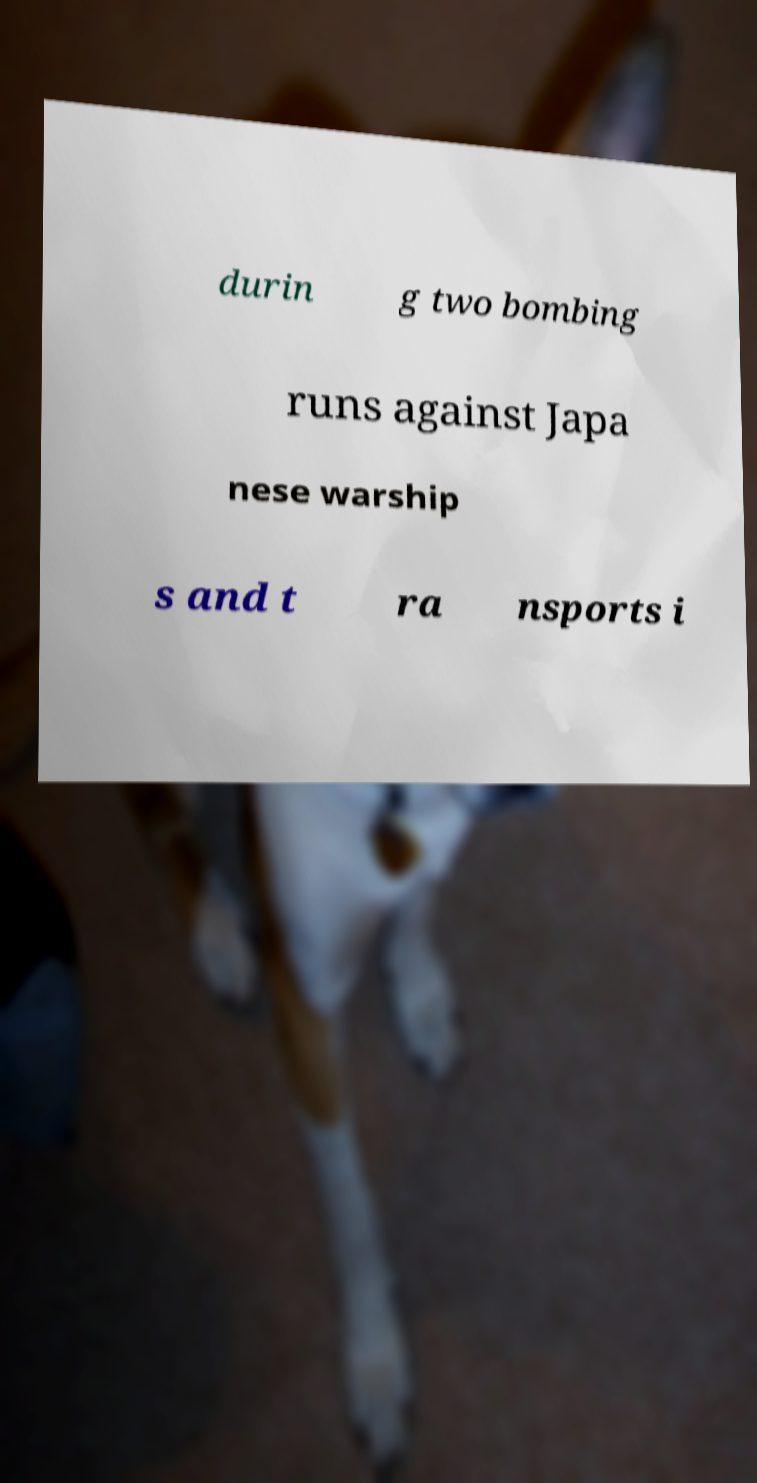Can you read and provide the text displayed in the image?This photo seems to have some interesting text. Can you extract and type it out for me? durin g two bombing runs against Japa nese warship s and t ra nsports i 